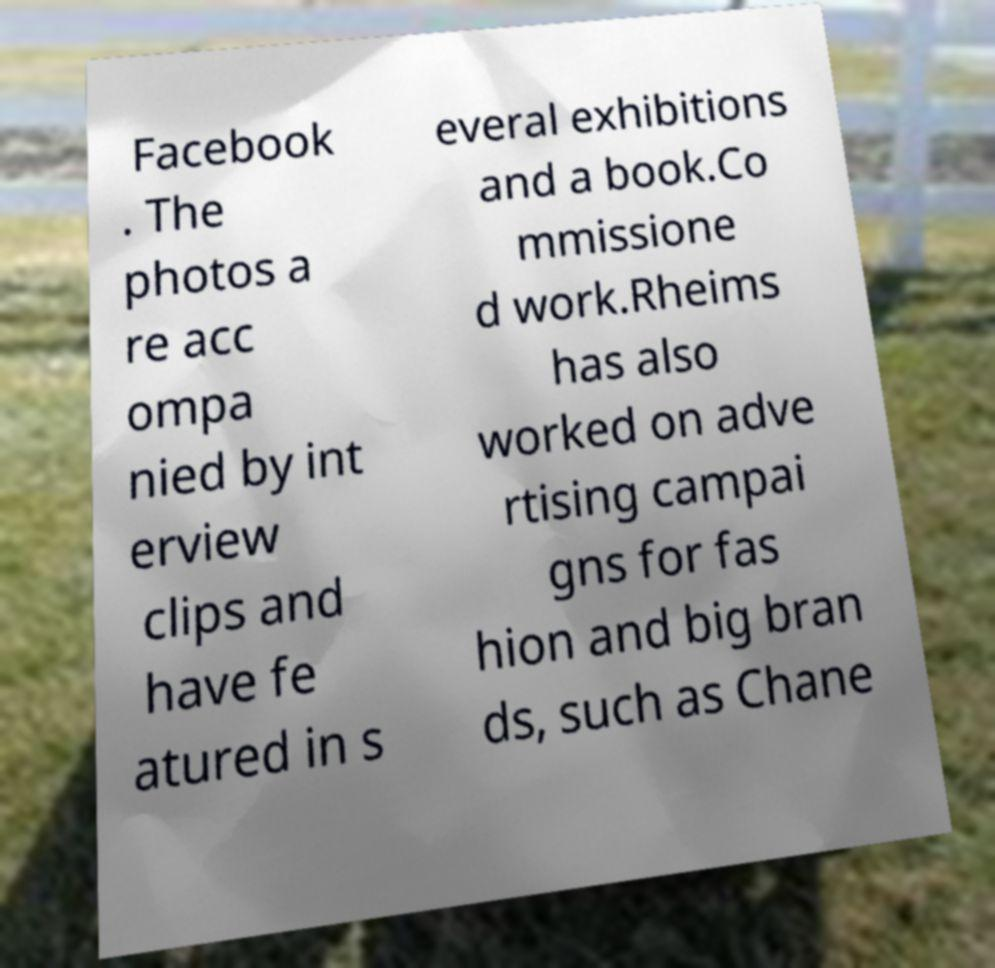What messages or text are displayed in this image? I need them in a readable, typed format. Facebook . The photos a re acc ompa nied by int erview clips and have fe atured in s everal exhibitions and a book.Co mmissione d work.Rheims has also worked on adve rtising campai gns for fas hion and big bran ds, such as Chane 